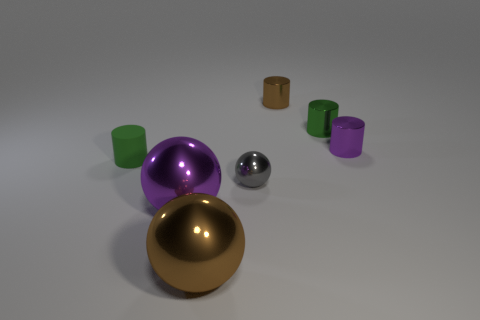The green shiny object is what size?
Your response must be concise. Small. There is a brown metallic thing that is the same shape as the tiny gray metal thing; what size is it?
Offer a terse response. Large. What number of brown objects are behind the small green cylinder that is right of the big brown metal thing?
Offer a very short reply. 1. Do the cylinder behind the green metal object and the tiny green thing to the right of the purple ball have the same material?
Ensure brevity in your answer.  Yes. How many gray metallic objects are the same shape as the rubber thing?
Make the answer very short. 0. What number of tiny spheres have the same color as the matte cylinder?
Give a very brief answer. 0. There is a large object in front of the purple sphere; is it the same shape as the green thing right of the purple metal sphere?
Ensure brevity in your answer.  No. There is a purple thing left of the brown thing behind the tiny green matte thing; how many metal spheres are in front of it?
Keep it short and to the point. 1. What is the material of the green cylinder to the left of the brown object behind the green cylinder left of the gray shiny thing?
Your response must be concise. Rubber. Does the cylinder that is left of the tiny gray metallic sphere have the same material as the small brown cylinder?
Your response must be concise. No. 